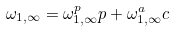<formula> <loc_0><loc_0><loc_500><loc_500>\omega _ { 1 , \infty } = \omega _ { 1 , \infty } ^ { p } p + \omega _ { 1 , \infty } ^ { a } c</formula> 